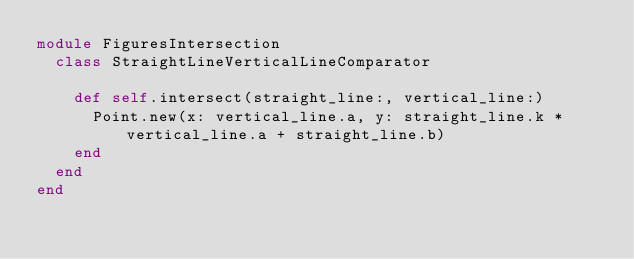<code> <loc_0><loc_0><loc_500><loc_500><_Ruby_>module FiguresIntersection
  class StraightLineVerticalLineComparator

    def self.intersect(straight_line:, vertical_line:)
      Point.new(x: vertical_line.a, y: straight_line.k * vertical_line.a + straight_line.b)
    end
  end
end</code> 